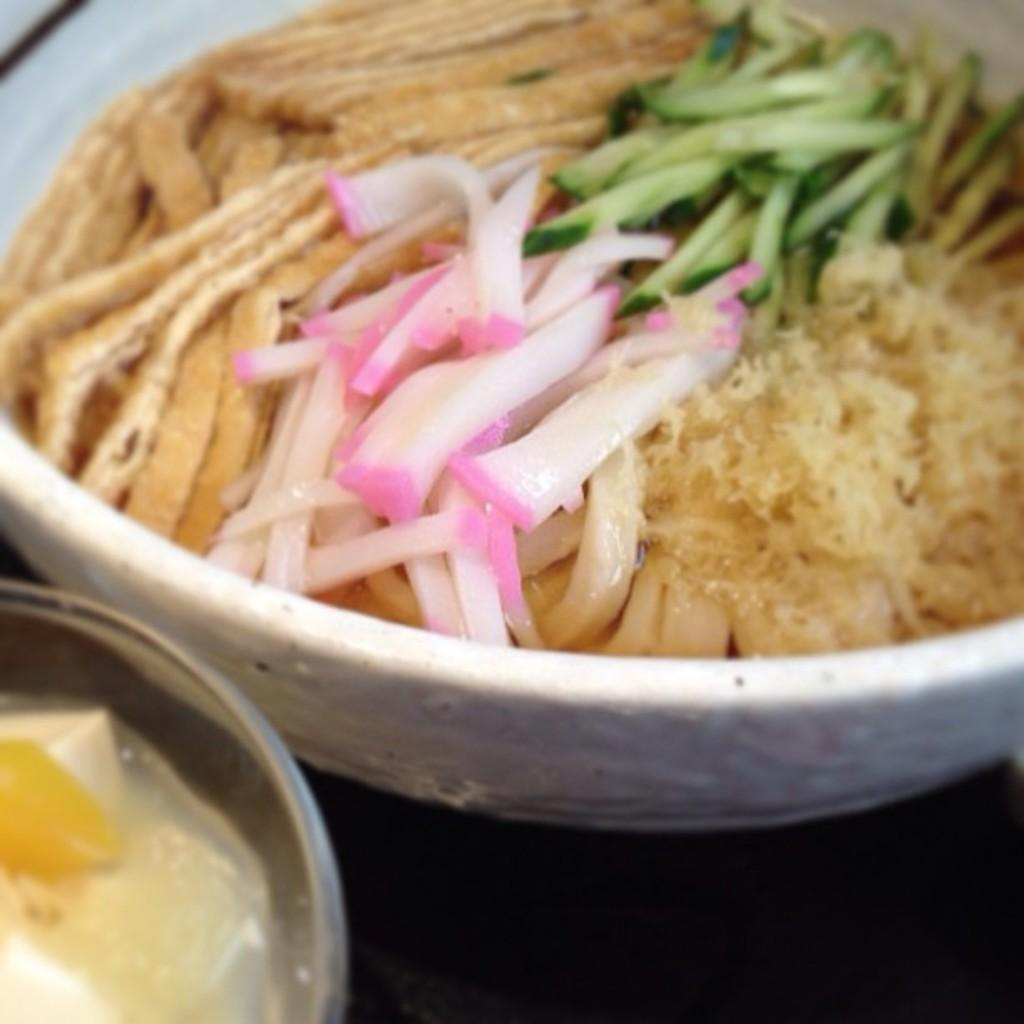What type of objects can be seen in the image? There are food items in the image. How are the food items arranged or contained? The food items are in bowls. Where are the bowls with food items located? The bowls are on a table. How many crates of quince are visible in the image? There are no crates or quince present in the image. 